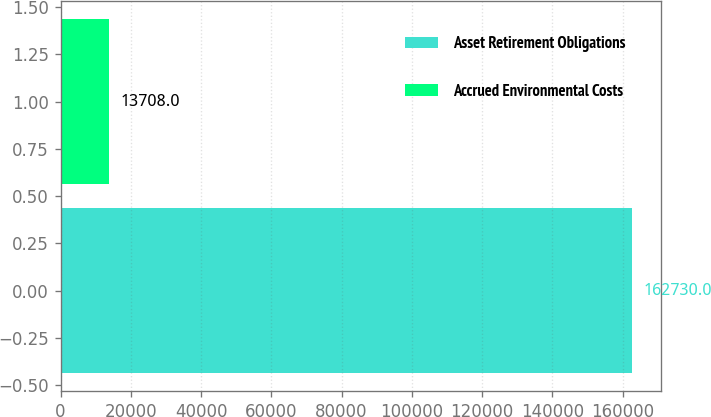Convert chart. <chart><loc_0><loc_0><loc_500><loc_500><bar_chart><fcel>Asset Retirement Obligations<fcel>Accrued Environmental Costs<nl><fcel>162730<fcel>13708<nl></chart> 